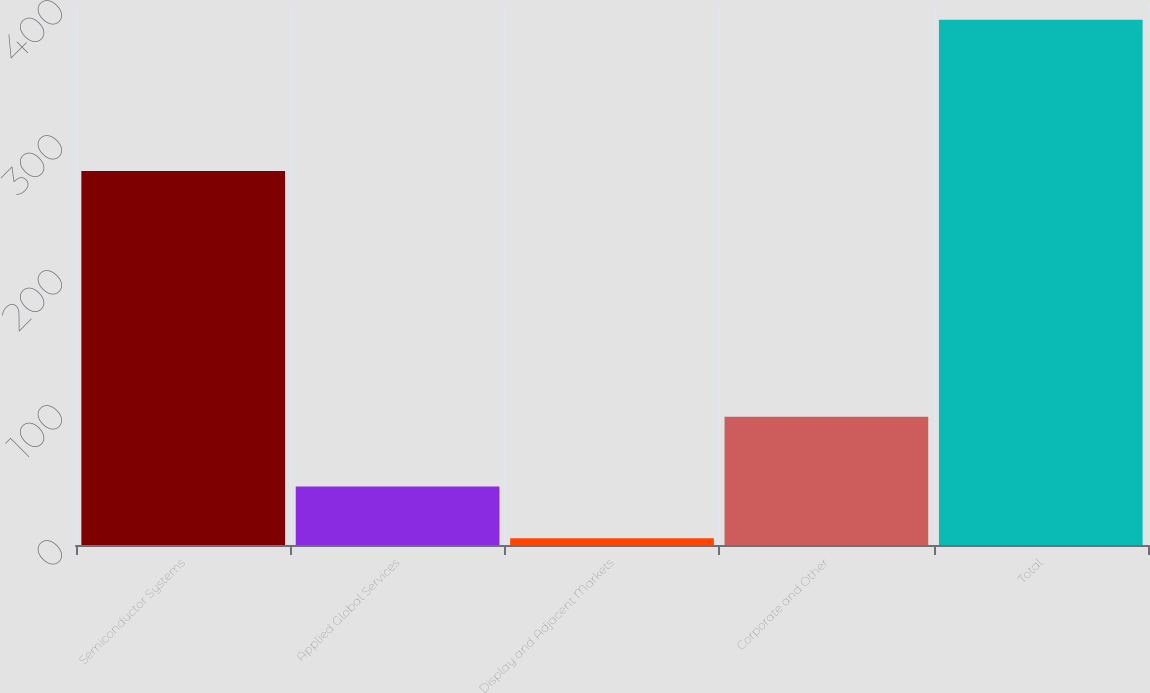Convert chart. <chart><loc_0><loc_0><loc_500><loc_500><bar_chart><fcel>Semiconductor Systems<fcel>Applied Global Services<fcel>Display and Adjacent Markets<fcel>Corporate and Other<fcel>Total<nl><fcel>277<fcel>43.4<fcel>5<fcel>95<fcel>389<nl></chart> 